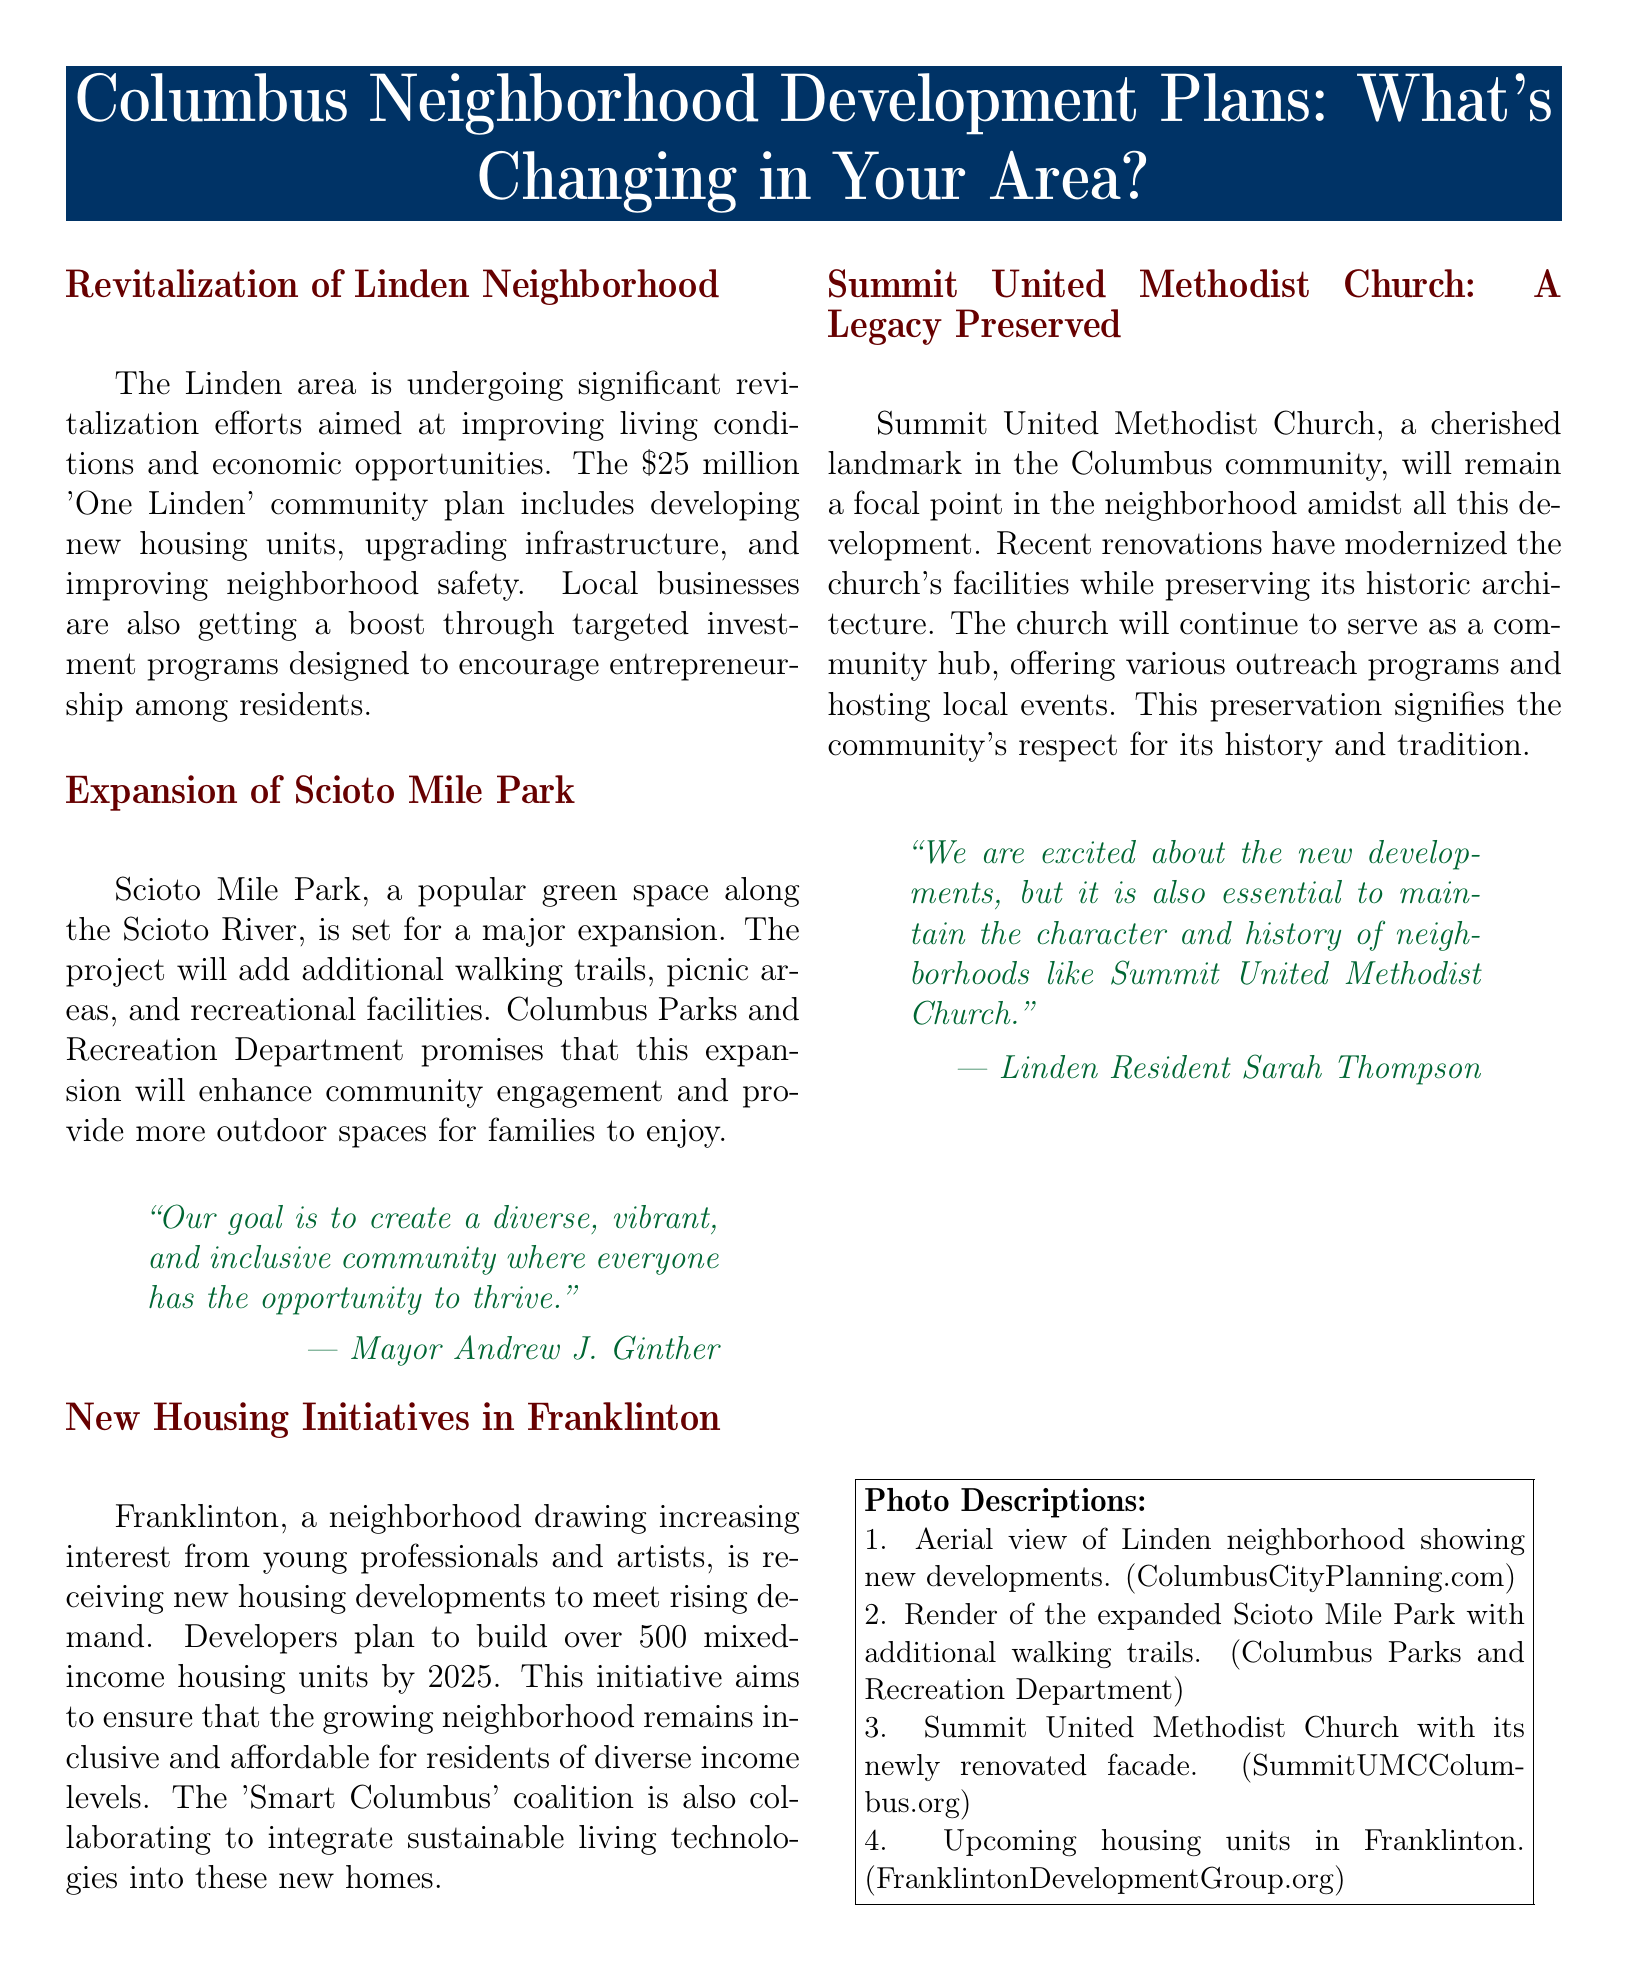What is the budget for the 'One Linden' community plan? The document states that the budget for the 'One Linden' community plan is $25 million.
Answer: $25 million What neighborhood is seeing new housing developments for young professionals? Franklinton is identified as the neighborhood receiving new housing developments for young professionals and artists.
Answer: Franklinton What will the expansion of Scioto Mile Park add? The expansion will add additional walking trails, picnic areas, and recreational facilities.
Answer: Walking trails, picnic areas, and recreational facilities Who is the mayor quoted in the document? The mayor quoted discussing community goals is Andrew J. Ginther.
Answer: Andrew J. Ginther How many mixed-income housing units are planned for Franklinton by 2025? The document reports that developers plan to build over 500 mixed-income housing units by 2025.
Answer: Over 500 What aspect of the Summit United Methodist Church is emphasized in the document? The document emphasizes that recent renovations have modernized the church's facilities while preserving its historic architecture.
Answer: Preserving its historic architecture What is a significant goal of the 'Smart Columbus' coalition in new developments? The coalition aims to integrate sustainable living technologies into the new homes.
Answer: Sustainable living technologies How does Summit United Methodist Church serve the community according to the document? The church continues to serve as a community hub offering various outreach programs and hosting local events.
Answer: Community hub 